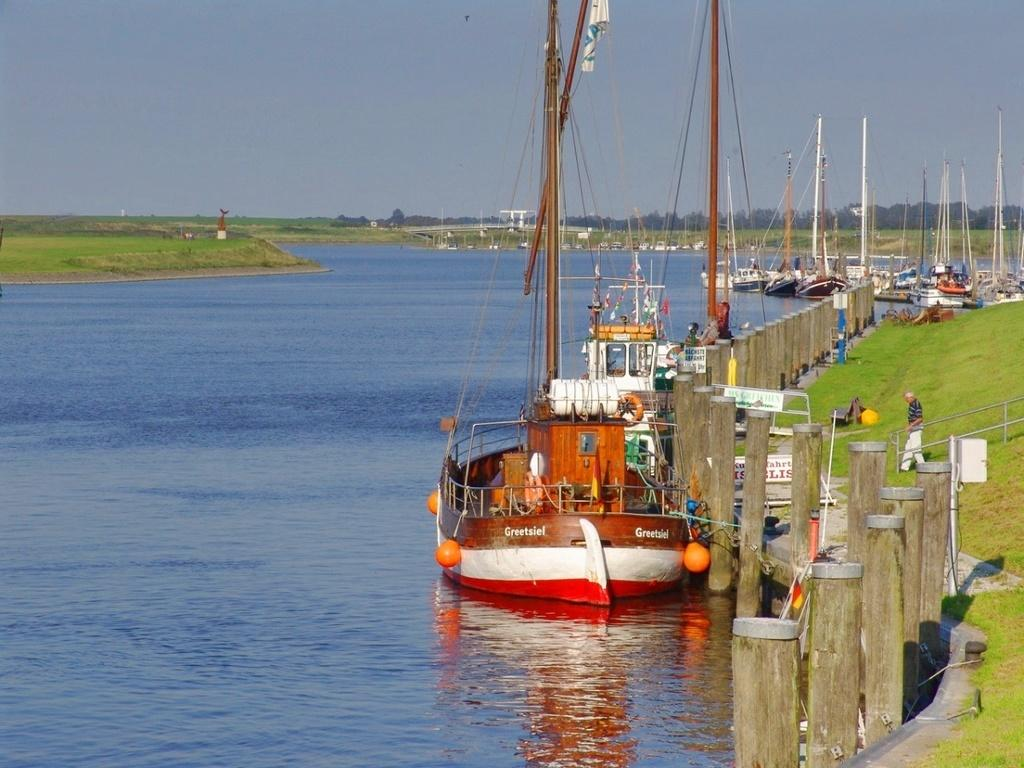What is the main subject in the image? There is a person in the image. What is the person sitting on in the image? There is a bench on the ground in the image. What can be seen on the water in the image? Boats are visible on water in the image. What type of natural scenery is visible in the background of the image? There are trees and the sky visible in the background of the image. Where are the frogs jumping in the image? There are no frogs present in the image. What type of flame can be seen near the person in the image? There is no flame visible in the image. 